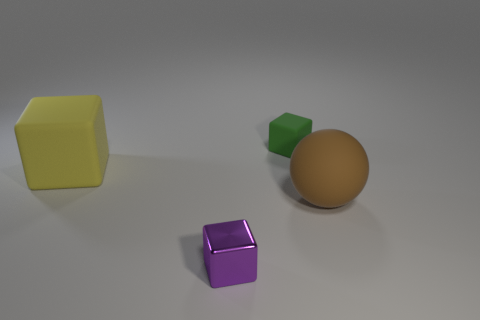There is a matte object that is to the left of the metal object; is it the same shape as the tiny green rubber thing to the left of the brown rubber sphere?
Offer a very short reply. Yes. There is a thing that is the same size as the purple cube; what shape is it?
Ensure brevity in your answer.  Cube. What number of metallic objects are either big green blocks or yellow objects?
Your answer should be compact. 0. Does the thing in front of the brown ball have the same material as the thing that is on the right side of the small green block?
Your answer should be very brief. No. What is the color of the ball that is made of the same material as the tiny green thing?
Your response must be concise. Brown. Is the number of big matte cubes that are right of the big brown matte sphere greater than the number of brown matte spheres that are behind the small matte thing?
Offer a terse response. No. Is there a tiny purple matte cylinder?
Make the answer very short. No. What number of objects are either brown things or blue things?
Offer a very short reply. 1. Is there a small matte object that has the same color as the big sphere?
Offer a very short reply. No. There is a small thing that is in front of the brown object; how many objects are behind it?
Your response must be concise. 3. 